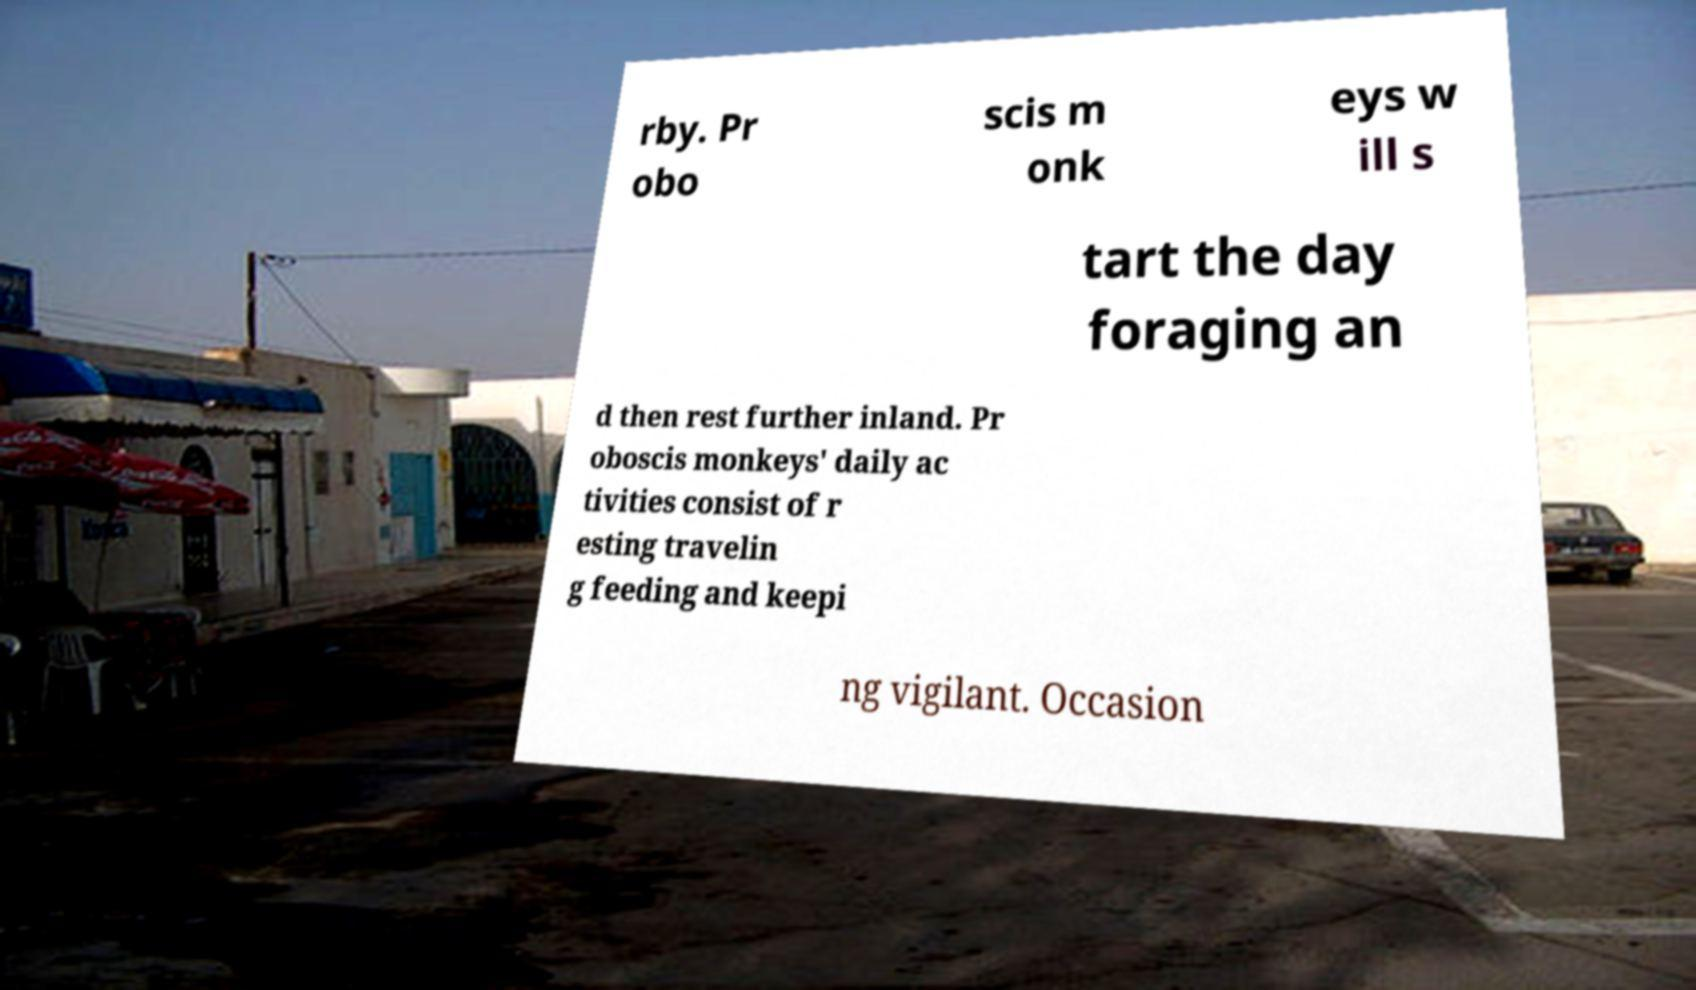For documentation purposes, I need the text within this image transcribed. Could you provide that? rby. Pr obo scis m onk eys w ill s tart the day foraging an d then rest further inland. Pr oboscis monkeys' daily ac tivities consist of r esting travelin g feeding and keepi ng vigilant. Occasion 